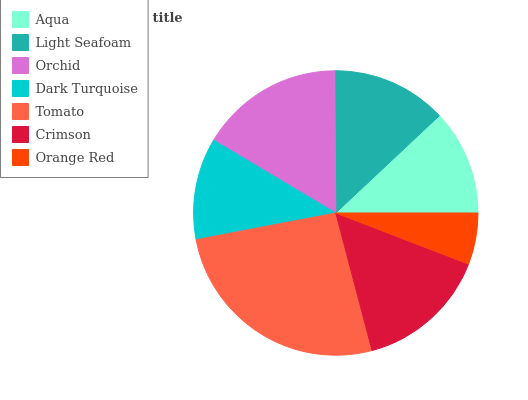Is Orange Red the minimum?
Answer yes or no. Yes. Is Tomato the maximum?
Answer yes or no. Yes. Is Light Seafoam the minimum?
Answer yes or no. No. Is Light Seafoam the maximum?
Answer yes or no. No. Is Light Seafoam greater than Aqua?
Answer yes or no. Yes. Is Aqua less than Light Seafoam?
Answer yes or no. Yes. Is Aqua greater than Light Seafoam?
Answer yes or no. No. Is Light Seafoam less than Aqua?
Answer yes or no. No. Is Light Seafoam the high median?
Answer yes or no. Yes. Is Light Seafoam the low median?
Answer yes or no. Yes. Is Orchid the high median?
Answer yes or no. No. Is Tomato the low median?
Answer yes or no. No. 